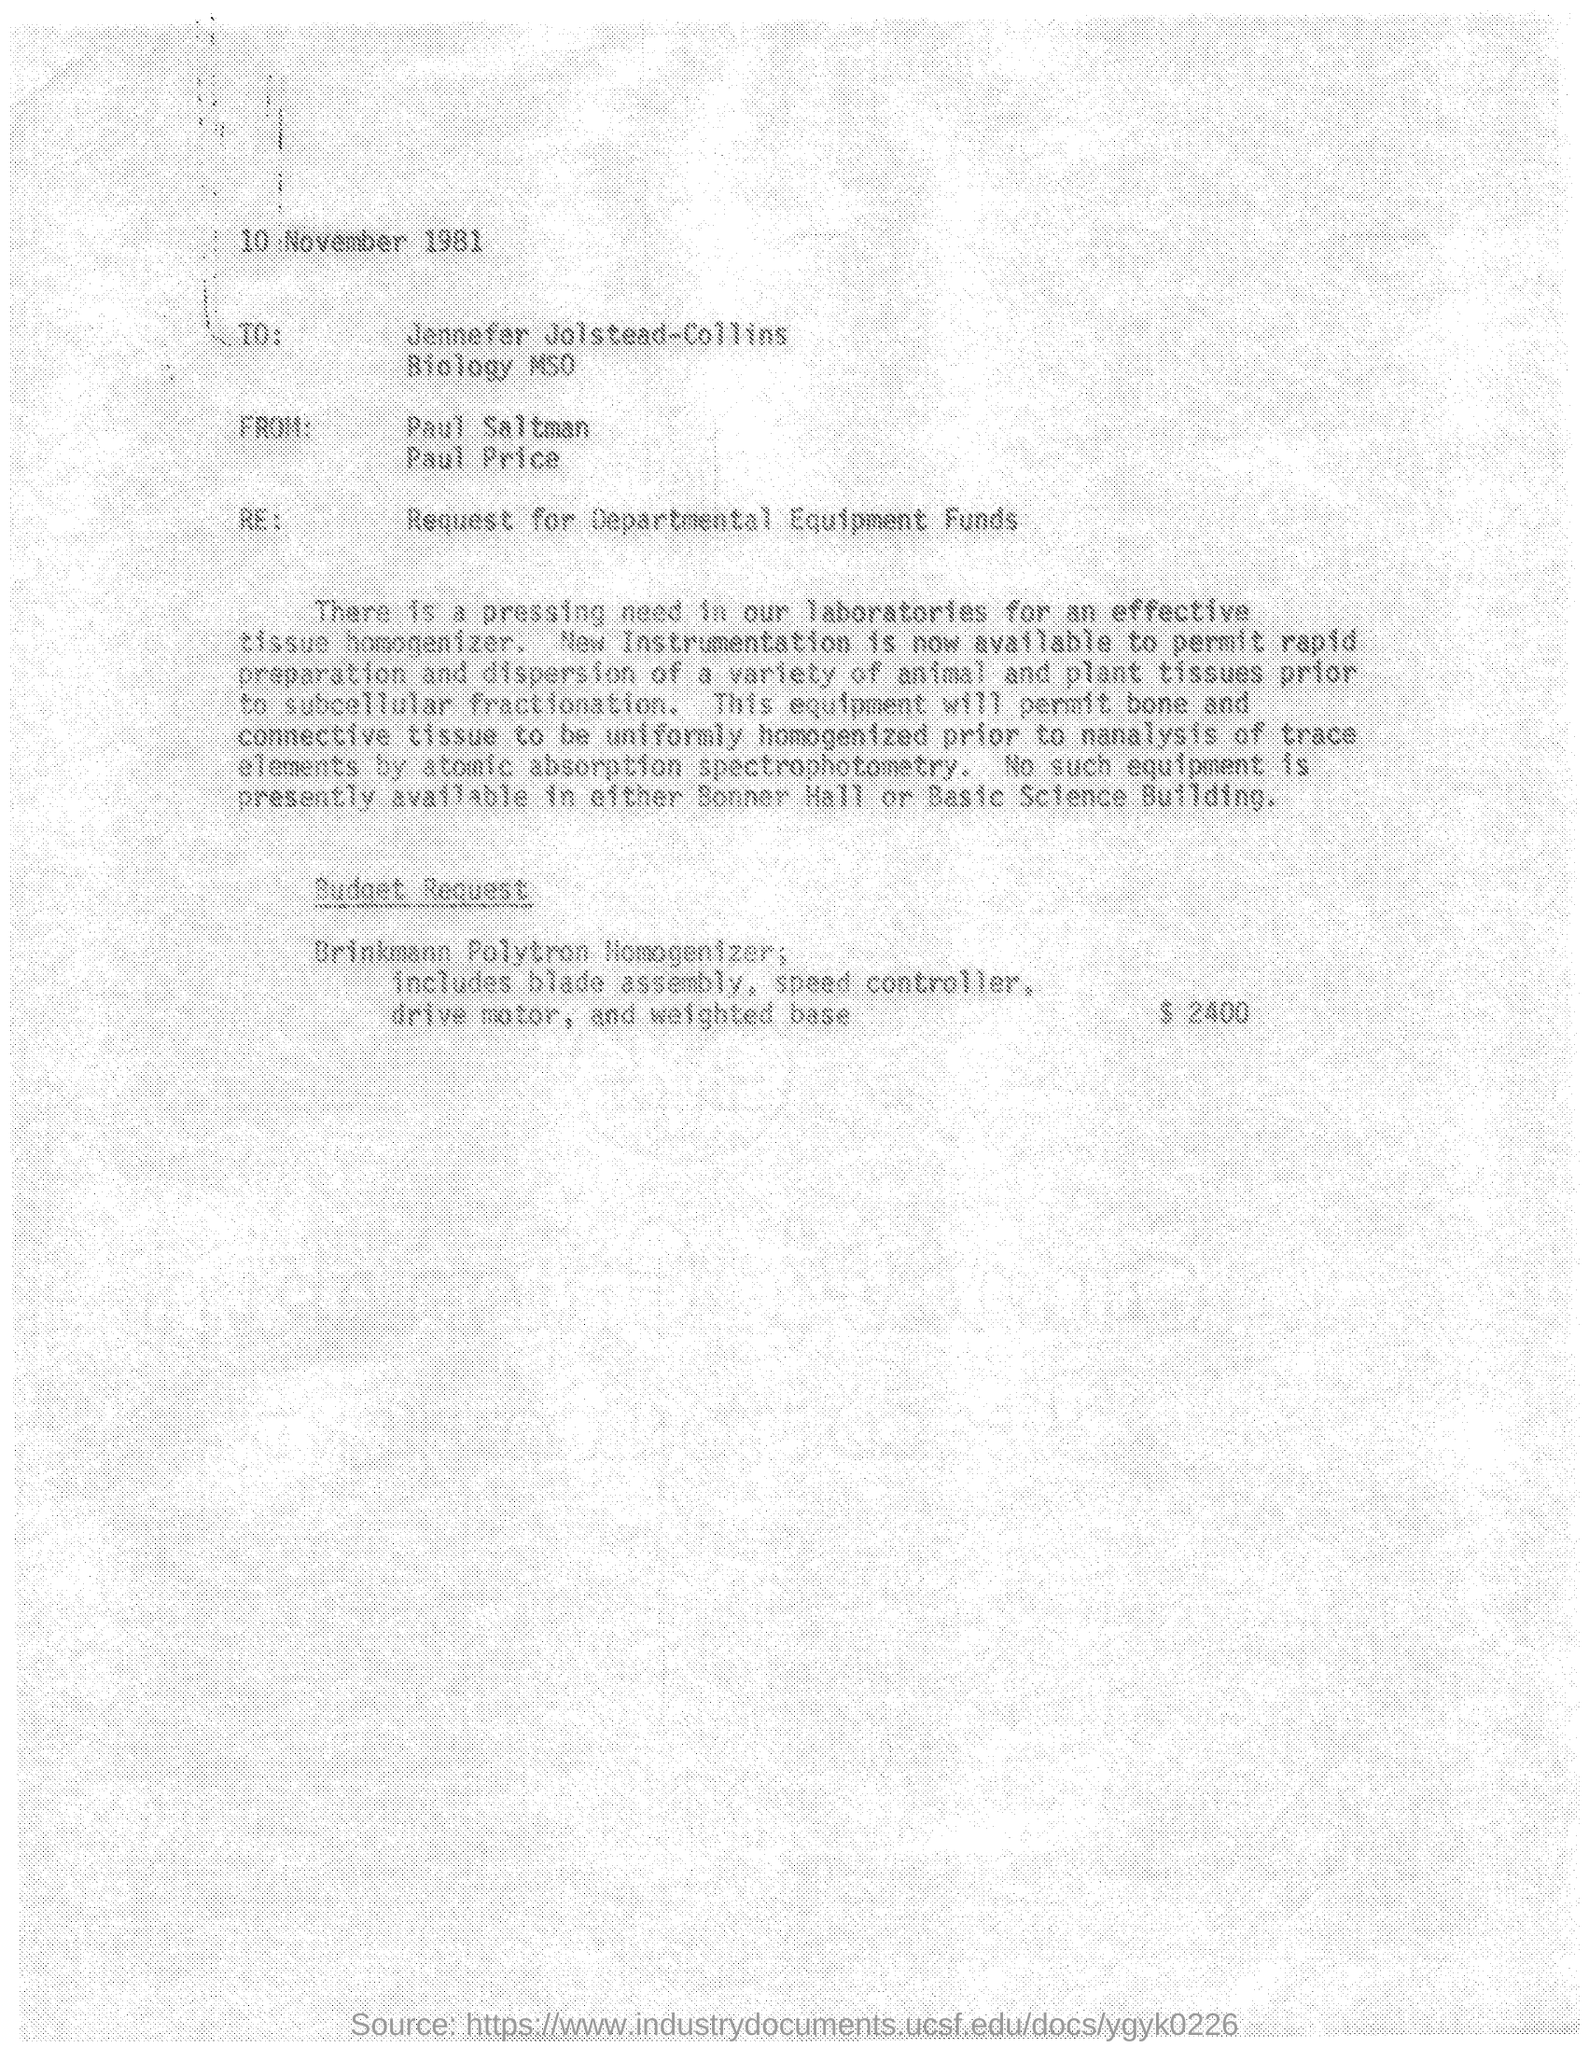Draw attention to some important aspects in this diagram. The letter was dated November 10, 1981. 